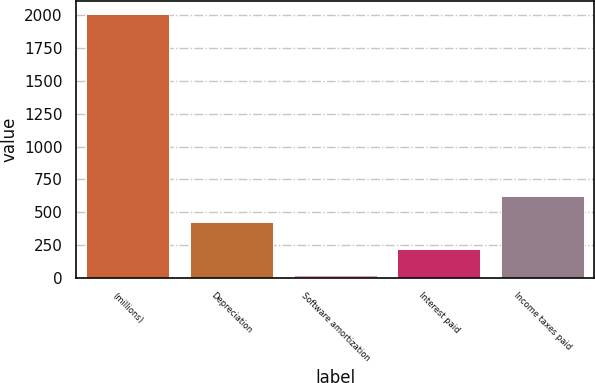Convert chart. <chart><loc_0><loc_0><loc_500><loc_500><bar_chart><fcel>(millions)<fcel>Depreciation<fcel>Software amortization<fcel>Interest paid<fcel>Income taxes paid<nl><fcel>2013<fcel>421.48<fcel>23.6<fcel>222.54<fcel>620.42<nl></chart> 